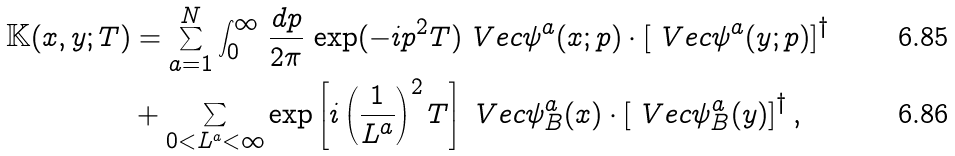Convert formula to latex. <formula><loc_0><loc_0><loc_500><loc_500>\mathbb { K } ( x , y ; T ) & = \sum _ { a = 1 } ^ { N } \int _ { 0 } ^ { \infty } \, \frac { d p } { 2 \pi } \, \exp ( - i p ^ { 2 } T ) \ V e c { \psi } ^ { a } ( x ; p ) \cdot \left [ \ V e c { \psi } ^ { a } ( y ; p ) \right ] ^ { \dagger } \\ & + \sum _ { 0 < L ^ { a } < \infty } \exp \left [ i \left ( \frac { 1 } { L ^ { a } } \right ) ^ { 2 } T \right ] \ V e c { \psi } _ { B } ^ { a } ( x ) \cdot \left [ \ V e c { \psi } _ { B } ^ { a } ( y ) \right ] ^ { \dagger } ,</formula> 